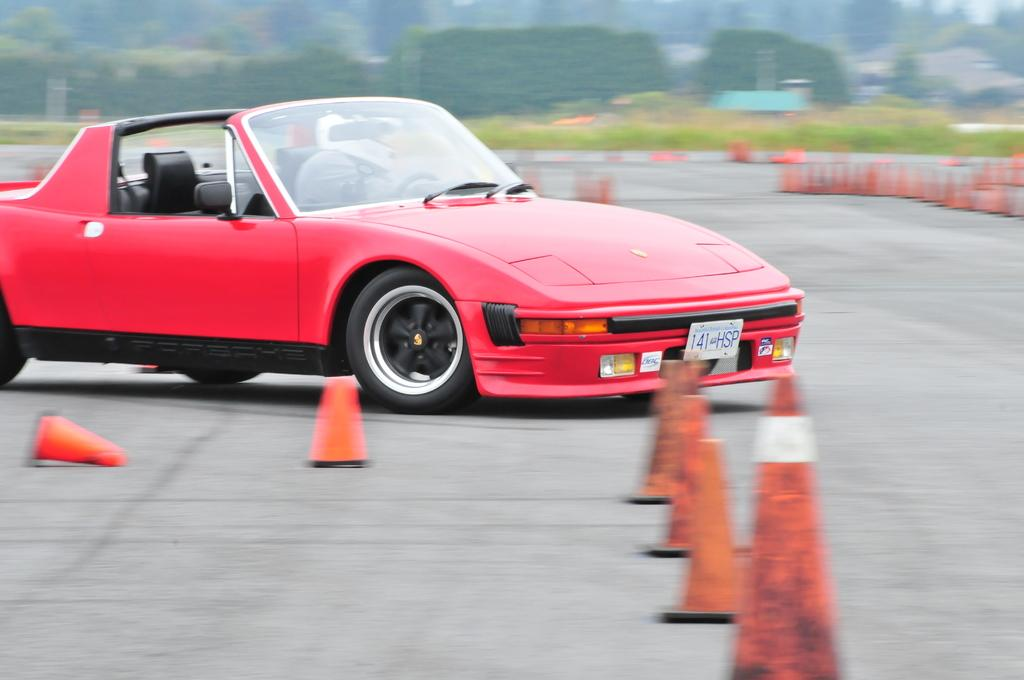What is at the bottom of the image? There is a road at the bottom of the image. What is on the road? There is a car on the road. What safety measures are present on the road? There are safety cones on the road. What can be seen in the background of the image? There are trees in the background of the image. How does the car say good-bye to the safety cones in the image? The car does not say good-bye to the safety cones in the image; it is simply driving on the road with the cones present. 